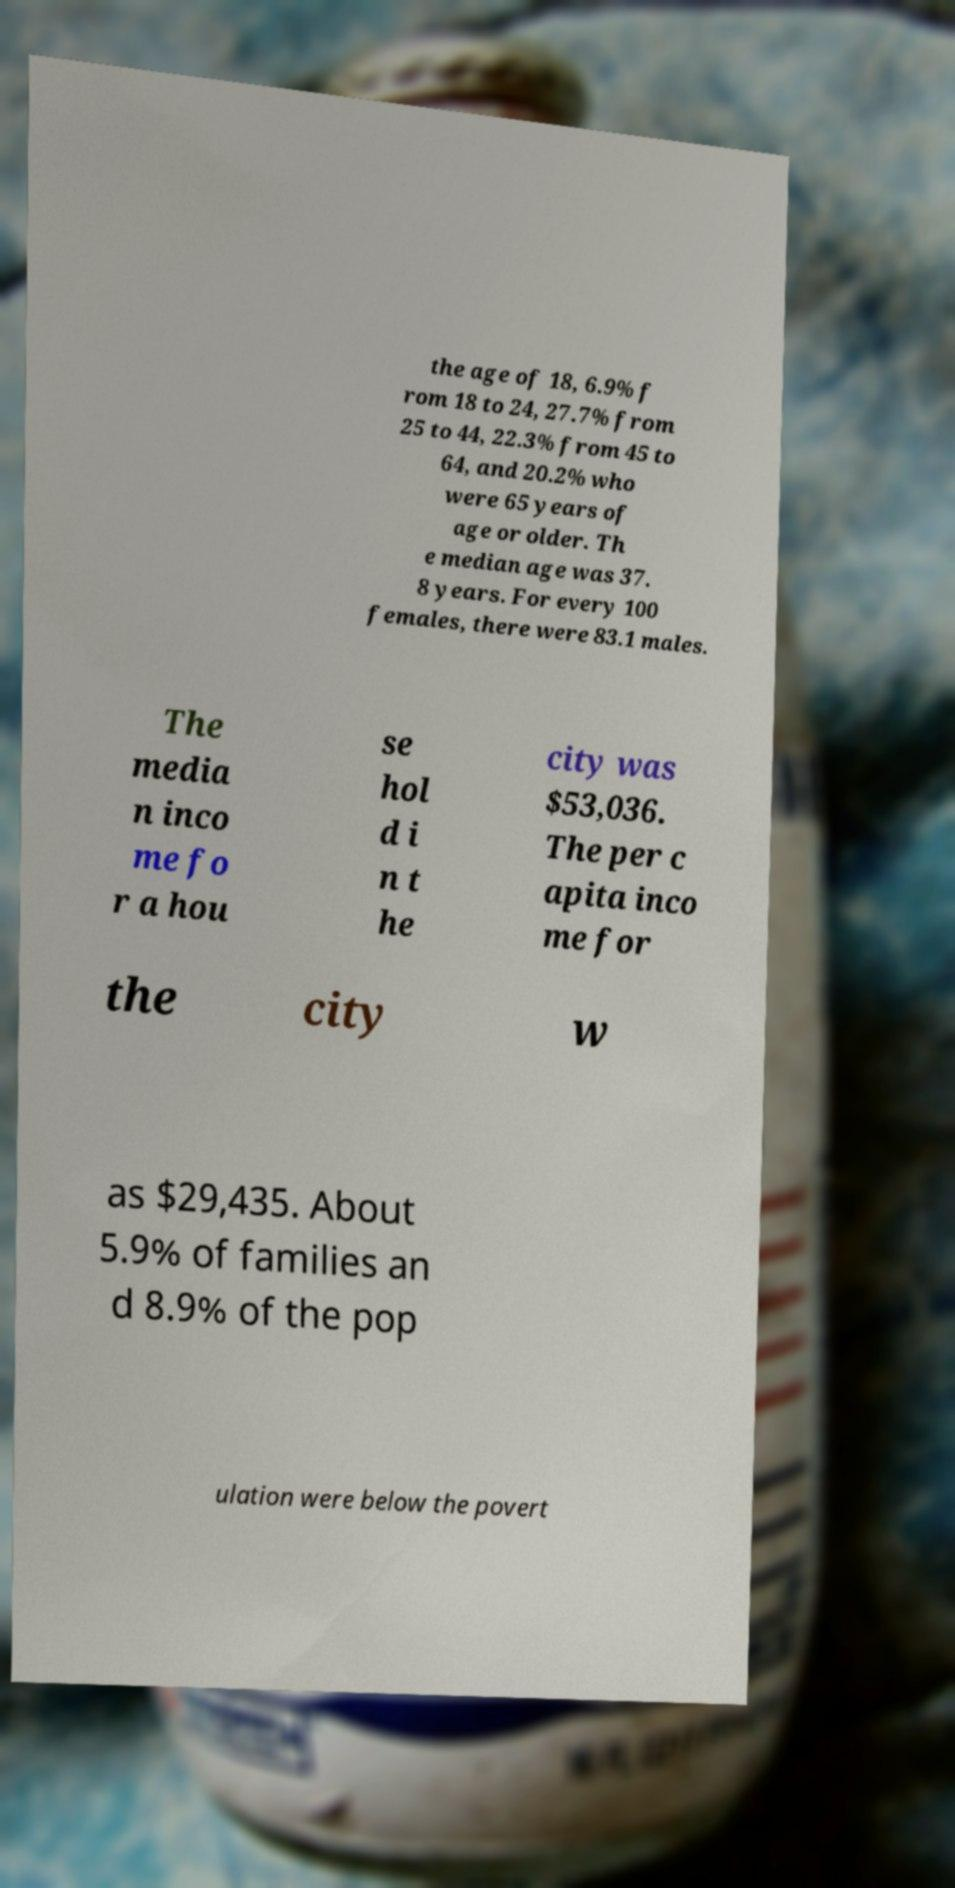Could you assist in decoding the text presented in this image and type it out clearly? the age of 18, 6.9% f rom 18 to 24, 27.7% from 25 to 44, 22.3% from 45 to 64, and 20.2% who were 65 years of age or older. Th e median age was 37. 8 years. For every 100 females, there were 83.1 males. The media n inco me fo r a hou se hol d i n t he city was $53,036. The per c apita inco me for the city w as $29,435. About 5.9% of families an d 8.9% of the pop ulation were below the povert 